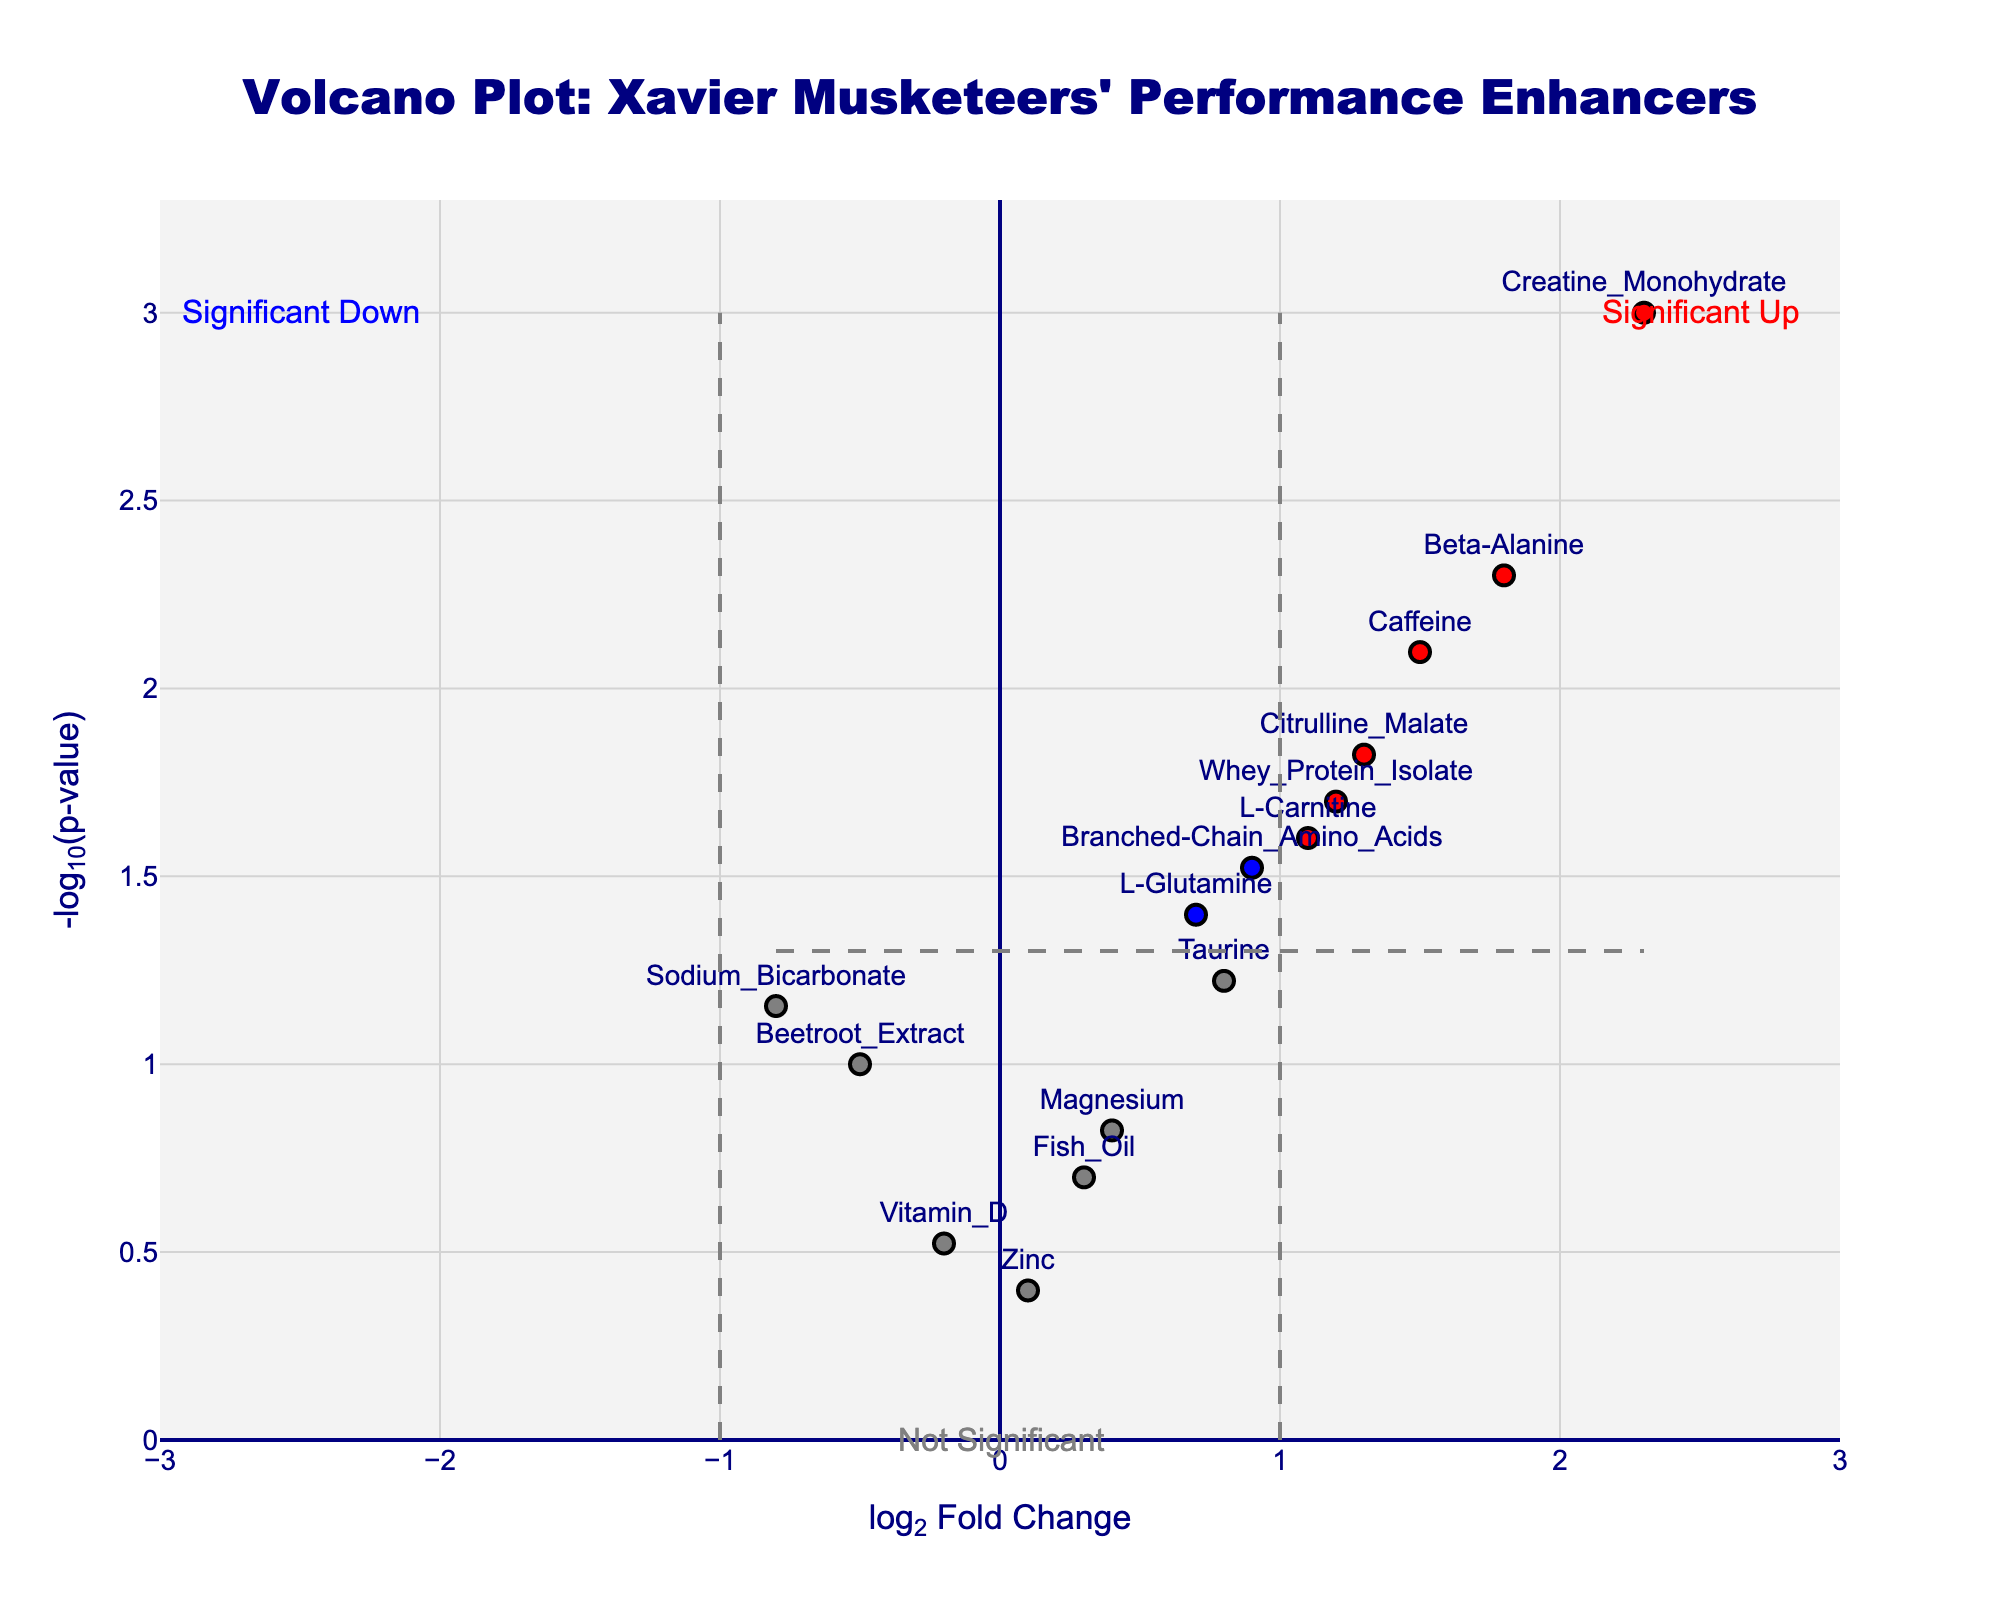What's the title of the figure? The title is displayed at the top of the figure in a large font. It reads "Volcano Plot: Xavier Musketeers' Performance Enhancers".
Answer: Volcano Plot: Xavier Musketeers' Performance Enhancers What do the x and y-axis represent? The x-axis represents the log2 fold change (log2FC), and the y-axis represents the negative log10 of the p-value (-log10(p-value)). This can be deduced from the axis labels.
Answer: The x-axis is log2 Fold Change, and the y-axis is -log10(p-value) How many proteins have a p-value less than 0.05? Proteins with p-values less than 0.05 are those that are displayed above the horizontal threshold line on the plot. Counting the points above this line reveals 10 such proteins.
Answer: 10 proteins Which protein has the highest log2 fold change? By looking at the x-axis values, the protein located farthest to the right has the highest log2 fold change. In this case, 'Creatine Monohydrate' has the highest log2FC of 2.3.
Answer: Creatine Monohydrate What is the log2 fold change and p-value of Beta-Alanine? The hover information or the marker’s label provides details. For Beta-Alanine, the log2 fold change is 1.8 and the p-value is 0.005.
Answer: log2FC: 1.8, p-value: 0.005 Which protein with a significant p-value (p < 0.05) has the smallest fold change? Among the proteins with p-values less than 0.05, 'L-Glutamine' has the smallest fold change, indicated by its lowest x-axis value among this group.
Answer: L-Glutamine How many proteins are colored red, and what does the red color signify? The plot indicates that proteins colored red meet both the significance thresholds for log2FC and p-value. Counting the red-marked proteins shows there are 5.
Answer: 5 proteins, red color signifies significant change What is the range of the y-axis values? The y-axis range can be observed directly from the plot. It starts from roughly 0 to a bit above 3, based on the highest value.
Answer: Approximately 0 to 3 Which proteins are marked as not significant, and what color are they? Proteins marked as not significant are colored grey. These proteins fall neither above the p-value threshold line nor have extreme log2FC values.
Answer: Various proteins like Fish Oil, Vitamin D, and Zinc, colored grey How many proteins are colored blue? Proteins that are colored blue have a significant p-value (less than 0.05) but do not meet the log2FC threshold. Counting the blue markers identifies 5 proteins.
Answer: 5 proteins 